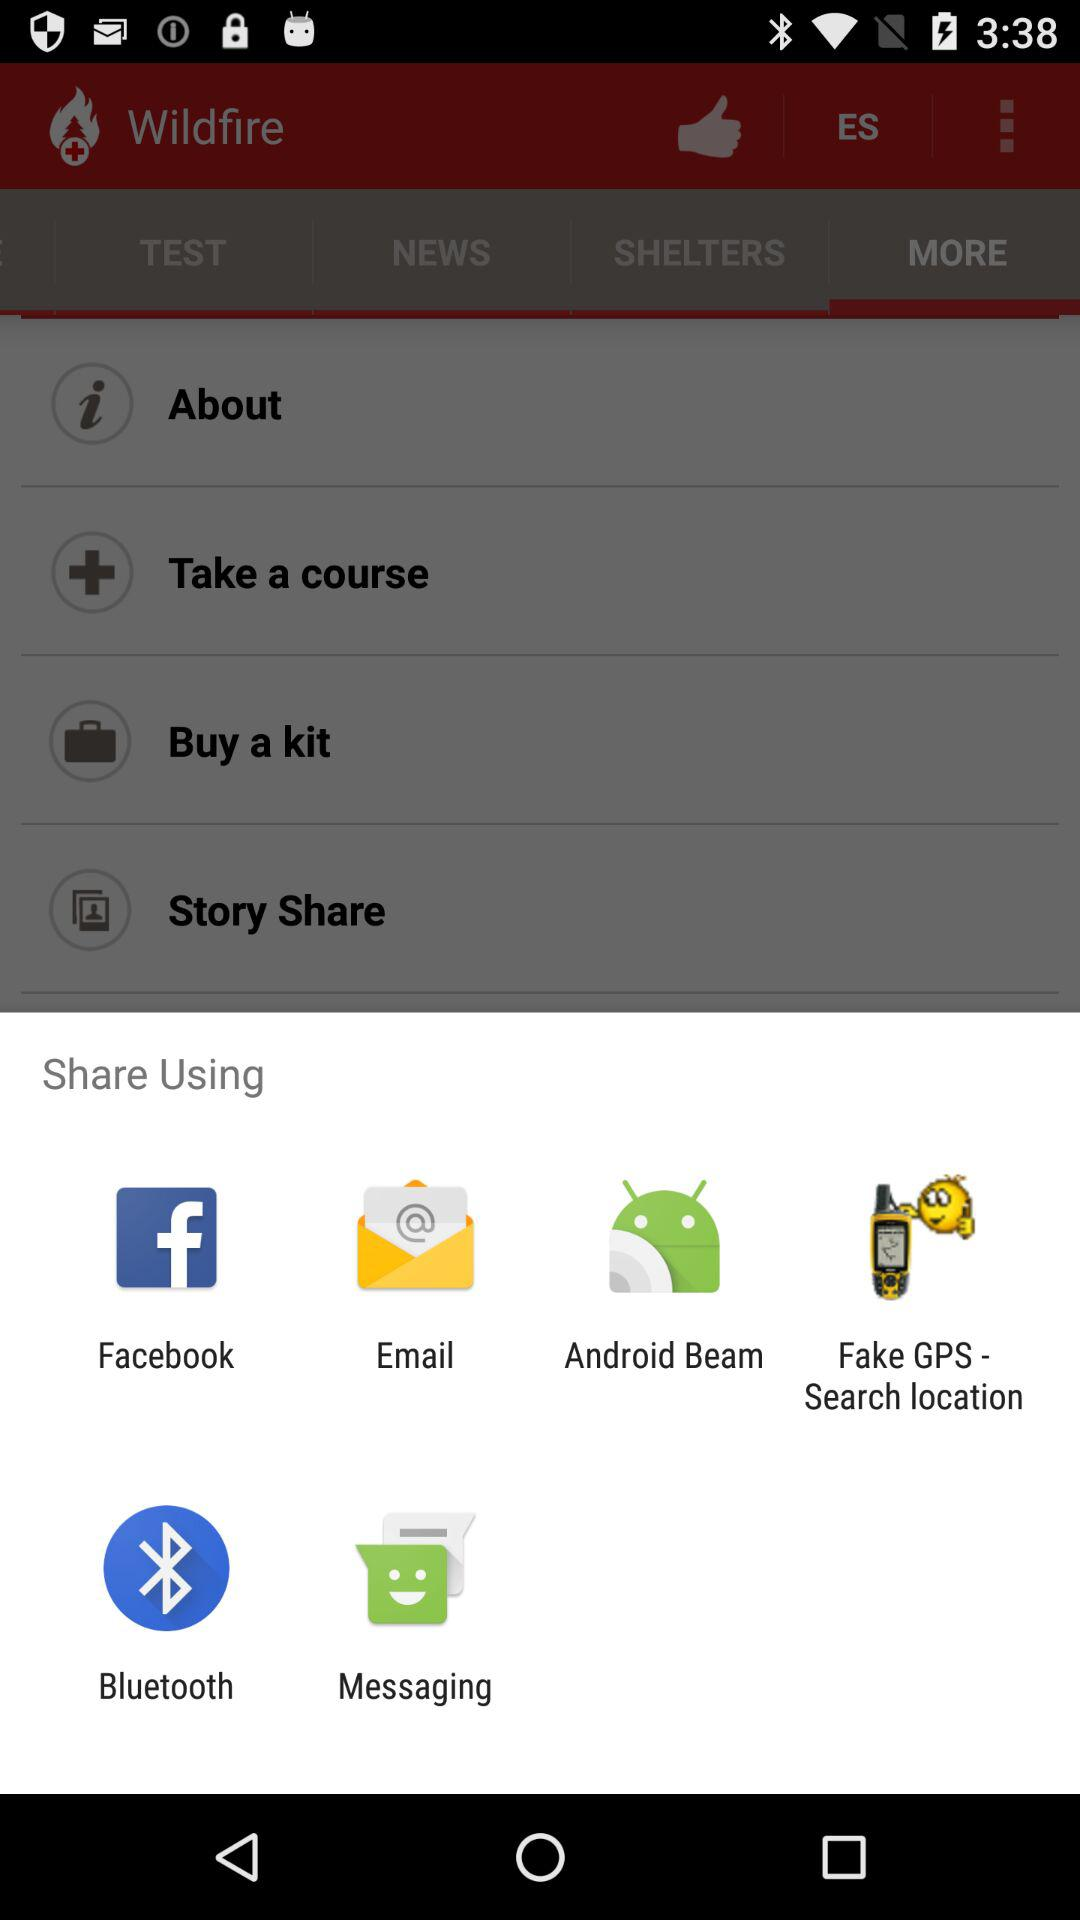Through which applications can we share? You can share through "Facebook", "Email", "Android Beam", " Fake GPS - Search location", "Bluetooth" and "Messaging". 